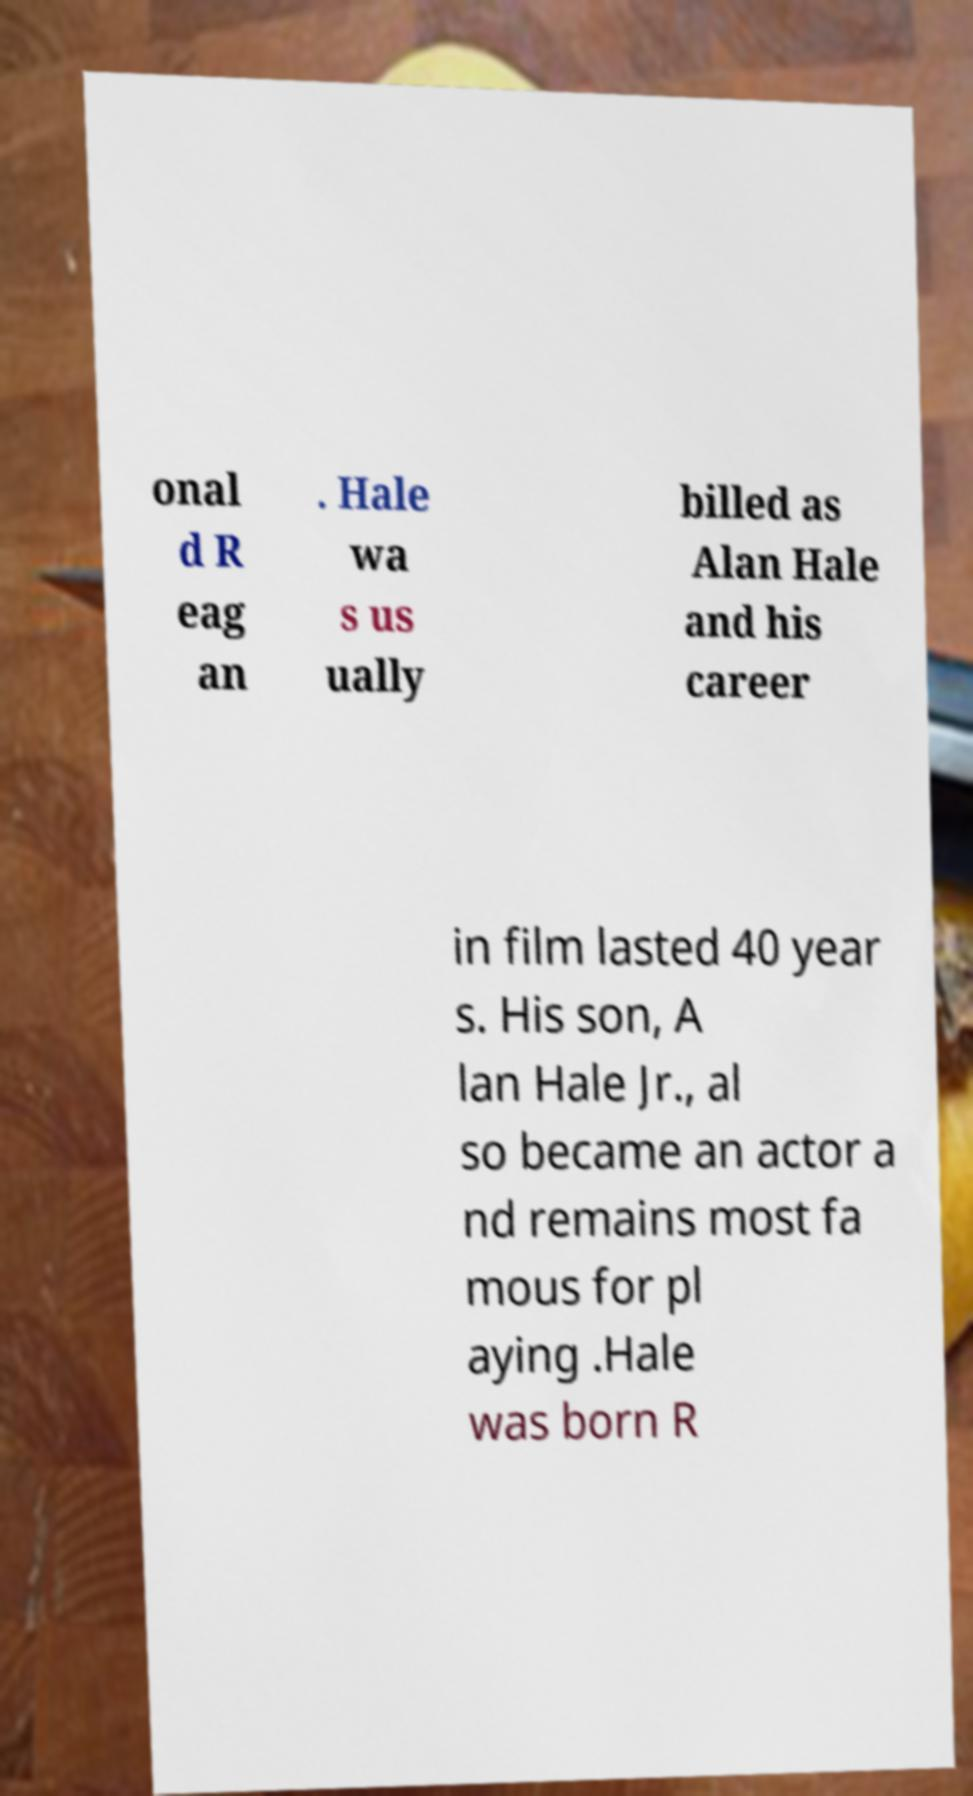There's text embedded in this image that I need extracted. Can you transcribe it verbatim? onal d R eag an . Hale wa s us ually billed as Alan Hale and his career in film lasted 40 year s. His son, A lan Hale Jr., al so became an actor a nd remains most fa mous for pl aying .Hale was born R 